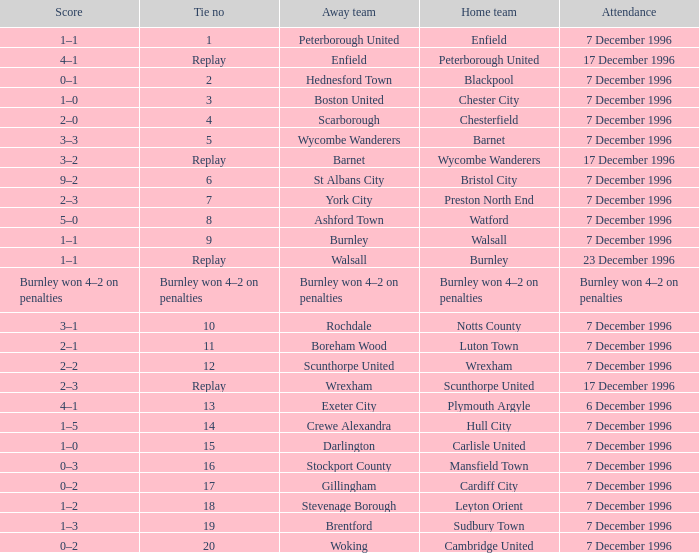Parse the full table. {'header': ['Score', 'Tie no', 'Away team', 'Home team', 'Attendance'], 'rows': [['1–1', '1', 'Peterborough United', 'Enfield', '7 December 1996'], ['4–1', 'Replay', 'Enfield', 'Peterborough United', '17 December 1996'], ['0–1', '2', 'Hednesford Town', 'Blackpool', '7 December 1996'], ['1–0', '3', 'Boston United', 'Chester City', '7 December 1996'], ['2–0', '4', 'Scarborough', 'Chesterfield', '7 December 1996'], ['3–3', '5', 'Wycombe Wanderers', 'Barnet', '7 December 1996'], ['3–2', 'Replay', 'Barnet', 'Wycombe Wanderers', '17 December 1996'], ['9–2', '6', 'St Albans City', 'Bristol City', '7 December 1996'], ['2–3', '7', 'York City', 'Preston North End', '7 December 1996'], ['5–0', '8', 'Ashford Town', 'Watford', '7 December 1996'], ['1–1', '9', 'Burnley', 'Walsall', '7 December 1996'], ['1–1', 'Replay', 'Walsall', 'Burnley', '23 December 1996'], ['Burnley won 4–2 on penalties', 'Burnley won 4–2 on penalties', 'Burnley won 4–2 on penalties', 'Burnley won 4–2 on penalties', 'Burnley won 4–2 on penalties'], ['3–1', '10', 'Rochdale', 'Notts County', '7 December 1996'], ['2–1', '11', 'Boreham Wood', 'Luton Town', '7 December 1996'], ['2–2', '12', 'Scunthorpe United', 'Wrexham', '7 December 1996'], ['2–3', 'Replay', 'Wrexham', 'Scunthorpe United', '17 December 1996'], ['4–1', '13', 'Exeter City', 'Plymouth Argyle', '6 December 1996'], ['1–5', '14', 'Crewe Alexandra', 'Hull City', '7 December 1996'], ['1–0', '15', 'Darlington', 'Carlisle United', '7 December 1996'], ['0–3', '16', 'Stockport County', 'Mansfield Town', '7 December 1996'], ['0–2', '17', 'Gillingham', 'Cardiff City', '7 December 1996'], ['1–2', '18', 'Stevenage Borough', 'Leyton Orient', '7 December 1996'], ['1–3', '19', 'Brentford', 'Sudbury Town', '7 December 1996'], ['0–2', '20', 'Woking', 'Cambridge United', '7 December 1996']]} What was the score of tie number 15? 1–0. 